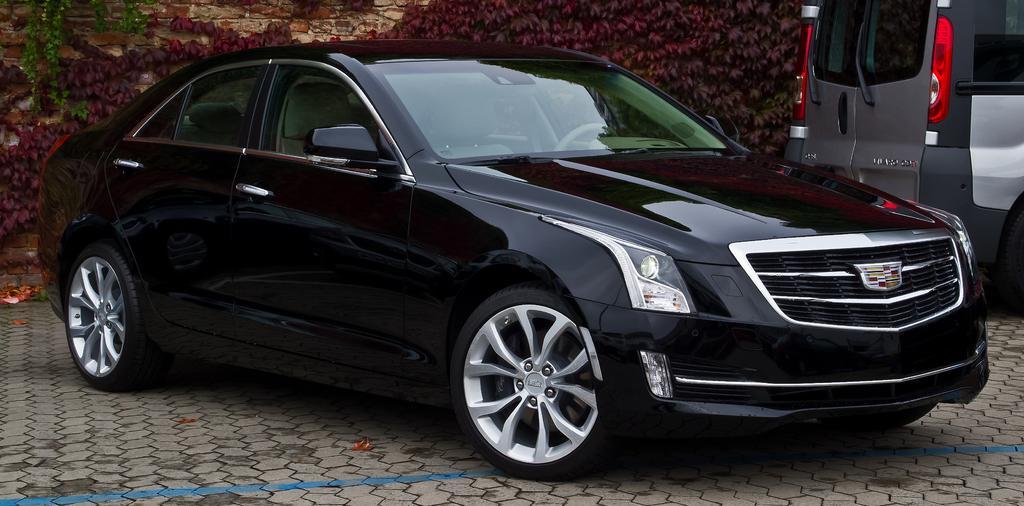How would you summarize this image in a sentence or two? In this image I can see a vehicle in black color, background I can see the other vehicle in black and gray color and I can see few plants in green color. 